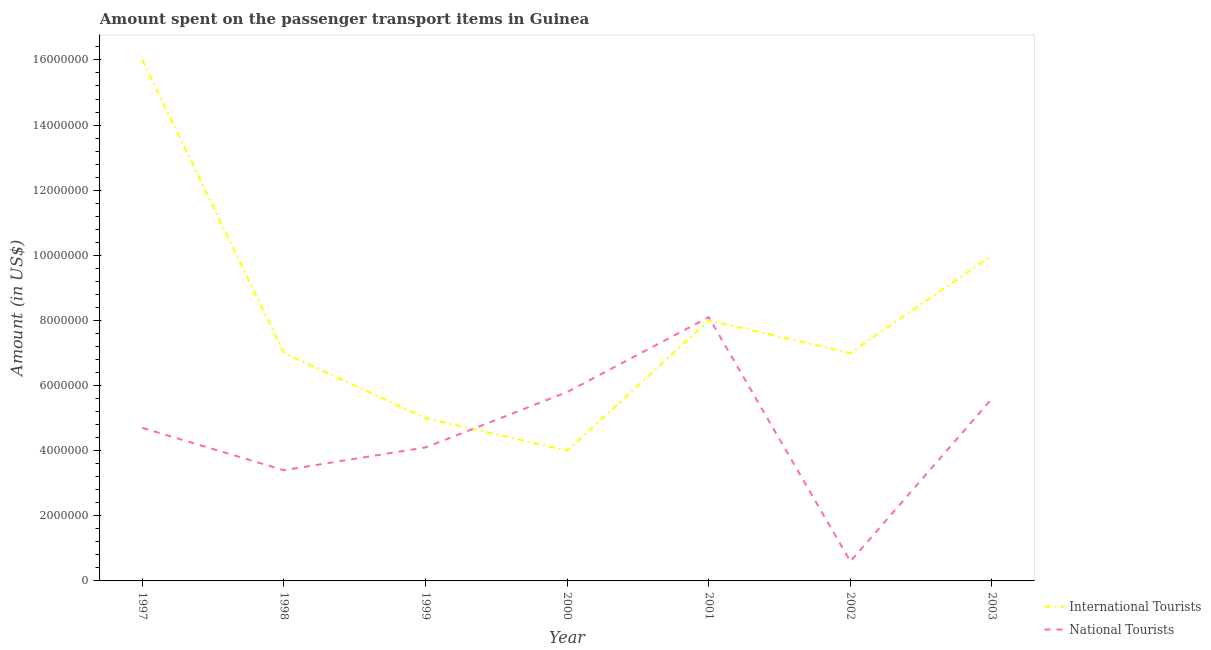Does the line corresponding to amount spent on transport items of international tourists intersect with the line corresponding to amount spent on transport items of national tourists?
Provide a succinct answer. Yes. Is the number of lines equal to the number of legend labels?
Your answer should be compact. Yes. What is the amount spent on transport items of international tourists in 1998?
Offer a very short reply. 7.00e+06. Across all years, what is the maximum amount spent on transport items of national tourists?
Provide a short and direct response. 8.10e+06. Across all years, what is the minimum amount spent on transport items of national tourists?
Offer a terse response. 6.00e+05. In which year was the amount spent on transport items of international tourists maximum?
Your answer should be compact. 1997. In which year was the amount spent on transport items of national tourists minimum?
Your answer should be very brief. 2002. What is the total amount spent on transport items of national tourists in the graph?
Provide a short and direct response. 3.23e+07. What is the difference between the amount spent on transport items of international tourists in 2002 and that in 2003?
Provide a succinct answer. -3.00e+06. What is the difference between the amount spent on transport items of national tourists in 1999 and the amount spent on transport items of international tourists in 1997?
Provide a short and direct response. -1.19e+07. What is the average amount spent on transport items of national tourists per year?
Ensure brevity in your answer.  4.61e+06. In the year 2003, what is the difference between the amount spent on transport items of international tourists and amount spent on transport items of national tourists?
Give a very brief answer. 4.40e+06. In how many years, is the amount spent on transport items of international tourists greater than 1600000 US$?
Your answer should be compact. 7. What is the ratio of the amount spent on transport items of national tourists in 1998 to that in 2001?
Provide a succinct answer. 0.42. Is the difference between the amount spent on transport items of national tourists in 1998 and 2002 greater than the difference between the amount spent on transport items of international tourists in 1998 and 2002?
Give a very brief answer. Yes. What is the difference between the highest and the lowest amount spent on transport items of national tourists?
Make the answer very short. 7.50e+06. Does the amount spent on transport items of international tourists monotonically increase over the years?
Make the answer very short. No. Is the amount spent on transport items of national tourists strictly greater than the amount spent on transport items of international tourists over the years?
Your response must be concise. No. How many lines are there?
Keep it short and to the point. 2. How many years are there in the graph?
Your response must be concise. 7. Are the values on the major ticks of Y-axis written in scientific E-notation?
Offer a very short reply. No. Does the graph contain grids?
Make the answer very short. No. Where does the legend appear in the graph?
Make the answer very short. Bottom right. How are the legend labels stacked?
Ensure brevity in your answer.  Vertical. What is the title of the graph?
Offer a terse response. Amount spent on the passenger transport items in Guinea. What is the Amount (in US$) in International Tourists in 1997?
Make the answer very short. 1.60e+07. What is the Amount (in US$) in National Tourists in 1997?
Offer a very short reply. 4.70e+06. What is the Amount (in US$) in National Tourists in 1998?
Keep it short and to the point. 3.40e+06. What is the Amount (in US$) of National Tourists in 1999?
Ensure brevity in your answer.  4.10e+06. What is the Amount (in US$) in International Tourists in 2000?
Provide a short and direct response. 4.00e+06. What is the Amount (in US$) of National Tourists in 2000?
Your answer should be compact. 5.80e+06. What is the Amount (in US$) in International Tourists in 2001?
Your response must be concise. 8.00e+06. What is the Amount (in US$) of National Tourists in 2001?
Your answer should be compact. 8.10e+06. What is the Amount (in US$) in International Tourists in 2002?
Ensure brevity in your answer.  7.00e+06. What is the Amount (in US$) of International Tourists in 2003?
Give a very brief answer. 1.00e+07. What is the Amount (in US$) in National Tourists in 2003?
Ensure brevity in your answer.  5.60e+06. Across all years, what is the maximum Amount (in US$) of International Tourists?
Make the answer very short. 1.60e+07. Across all years, what is the maximum Amount (in US$) in National Tourists?
Make the answer very short. 8.10e+06. Across all years, what is the minimum Amount (in US$) of National Tourists?
Make the answer very short. 6.00e+05. What is the total Amount (in US$) of International Tourists in the graph?
Provide a succinct answer. 5.70e+07. What is the total Amount (in US$) in National Tourists in the graph?
Offer a very short reply. 3.23e+07. What is the difference between the Amount (in US$) in International Tourists in 1997 and that in 1998?
Your answer should be compact. 9.00e+06. What is the difference between the Amount (in US$) of National Tourists in 1997 and that in 1998?
Provide a succinct answer. 1.30e+06. What is the difference between the Amount (in US$) in International Tourists in 1997 and that in 1999?
Make the answer very short. 1.10e+07. What is the difference between the Amount (in US$) in National Tourists in 1997 and that in 1999?
Ensure brevity in your answer.  6.00e+05. What is the difference between the Amount (in US$) in National Tourists in 1997 and that in 2000?
Offer a very short reply. -1.10e+06. What is the difference between the Amount (in US$) in National Tourists in 1997 and that in 2001?
Provide a short and direct response. -3.40e+06. What is the difference between the Amount (in US$) of International Tourists in 1997 and that in 2002?
Your answer should be compact. 9.00e+06. What is the difference between the Amount (in US$) of National Tourists in 1997 and that in 2002?
Provide a short and direct response. 4.10e+06. What is the difference between the Amount (in US$) in International Tourists in 1997 and that in 2003?
Provide a succinct answer. 6.00e+06. What is the difference between the Amount (in US$) in National Tourists in 1997 and that in 2003?
Offer a very short reply. -9.00e+05. What is the difference between the Amount (in US$) in International Tourists in 1998 and that in 1999?
Ensure brevity in your answer.  2.00e+06. What is the difference between the Amount (in US$) in National Tourists in 1998 and that in 1999?
Your response must be concise. -7.00e+05. What is the difference between the Amount (in US$) of National Tourists in 1998 and that in 2000?
Provide a succinct answer. -2.40e+06. What is the difference between the Amount (in US$) in International Tourists in 1998 and that in 2001?
Keep it short and to the point. -1.00e+06. What is the difference between the Amount (in US$) in National Tourists in 1998 and that in 2001?
Your answer should be compact. -4.70e+06. What is the difference between the Amount (in US$) in National Tourists in 1998 and that in 2002?
Offer a very short reply. 2.80e+06. What is the difference between the Amount (in US$) in National Tourists in 1998 and that in 2003?
Provide a succinct answer. -2.20e+06. What is the difference between the Amount (in US$) in National Tourists in 1999 and that in 2000?
Offer a very short reply. -1.70e+06. What is the difference between the Amount (in US$) in National Tourists in 1999 and that in 2001?
Ensure brevity in your answer.  -4.00e+06. What is the difference between the Amount (in US$) of National Tourists in 1999 and that in 2002?
Offer a very short reply. 3.50e+06. What is the difference between the Amount (in US$) in International Tourists in 1999 and that in 2003?
Your response must be concise. -5.00e+06. What is the difference between the Amount (in US$) of National Tourists in 1999 and that in 2003?
Your answer should be very brief. -1.50e+06. What is the difference between the Amount (in US$) in International Tourists in 2000 and that in 2001?
Provide a succinct answer. -4.00e+06. What is the difference between the Amount (in US$) of National Tourists in 2000 and that in 2001?
Give a very brief answer. -2.30e+06. What is the difference between the Amount (in US$) in International Tourists in 2000 and that in 2002?
Your answer should be compact. -3.00e+06. What is the difference between the Amount (in US$) in National Tourists in 2000 and that in 2002?
Your answer should be compact. 5.20e+06. What is the difference between the Amount (in US$) of International Tourists in 2000 and that in 2003?
Offer a very short reply. -6.00e+06. What is the difference between the Amount (in US$) of National Tourists in 2001 and that in 2002?
Your answer should be very brief. 7.50e+06. What is the difference between the Amount (in US$) of International Tourists in 2001 and that in 2003?
Make the answer very short. -2.00e+06. What is the difference between the Amount (in US$) in National Tourists in 2001 and that in 2003?
Offer a terse response. 2.50e+06. What is the difference between the Amount (in US$) in International Tourists in 2002 and that in 2003?
Ensure brevity in your answer.  -3.00e+06. What is the difference between the Amount (in US$) in National Tourists in 2002 and that in 2003?
Your answer should be compact. -5.00e+06. What is the difference between the Amount (in US$) in International Tourists in 1997 and the Amount (in US$) in National Tourists in 1998?
Your response must be concise. 1.26e+07. What is the difference between the Amount (in US$) in International Tourists in 1997 and the Amount (in US$) in National Tourists in 1999?
Your response must be concise. 1.19e+07. What is the difference between the Amount (in US$) of International Tourists in 1997 and the Amount (in US$) of National Tourists in 2000?
Your answer should be very brief. 1.02e+07. What is the difference between the Amount (in US$) of International Tourists in 1997 and the Amount (in US$) of National Tourists in 2001?
Make the answer very short. 7.90e+06. What is the difference between the Amount (in US$) in International Tourists in 1997 and the Amount (in US$) in National Tourists in 2002?
Provide a succinct answer. 1.54e+07. What is the difference between the Amount (in US$) in International Tourists in 1997 and the Amount (in US$) in National Tourists in 2003?
Your answer should be very brief. 1.04e+07. What is the difference between the Amount (in US$) in International Tourists in 1998 and the Amount (in US$) in National Tourists in 1999?
Keep it short and to the point. 2.90e+06. What is the difference between the Amount (in US$) of International Tourists in 1998 and the Amount (in US$) of National Tourists in 2000?
Your answer should be very brief. 1.20e+06. What is the difference between the Amount (in US$) of International Tourists in 1998 and the Amount (in US$) of National Tourists in 2001?
Your answer should be very brief. -1.10e+06. What is the difference between the Amount (in US$) in International Tourists in 1998 and the Amount (in US$) in National Tourists in 2002?
Offer a very short reply. 6.40e+06. What is the difference between the Amount (in US$) of International Tourists in 1998 and the Amount (in US$) of National Tourists in 2003?
Ensure brevity in your answer.  1.40e+06. What is the difference between the Amount (in US$) of International Tourists in 1999 and the Amount (in US$) of National Tourists in 2000?
Provide a short and direct response. -8.00e+05. What is the difference between the Amount (in US$) in International Tourists in 1999 and the Amount (in US$) in National Tourists in 2001?
Provide a succinct answer. -3.10e+06. What is the difference between the Amount (in US$) in International Tourists in 1999 and the Amount (in US$) in National Tourists in 2002?
Your response must be concise. 4.40e+06. What is the difference between the Amount (in US$) of International Tourists in 1999 and the Amount (in US$) of National Tourists in 2003?
Your answer should be compact. -6.00e+05. What is the difference between the Amount (in US$) in International Tourists in 2000 and the Amount (in US$) in National Tourists in 2001?
Give a very brief answer. -4.10e+06. What is the difference between the Amount (in US$) in International Tourists in 2000 and the Amount (in US$) in National Tourists in 2002?
Offer a very short reply. 3.40e+06. What is the difference between the Amount (in US$) in International Tourists in 2000 and the Amount (in US$) in National Tourists in 2003?
Keep it short and to the point. -1.60e+06. What is the difference between the Amount (in US$) in International Tourists in 2001 and the Amount (in US$) in National Tourists in 2002?
Make the answer very short. 7.40e+06. What is the difference between the Amount (in US$) in International Tourists in 2001 and the Amount (in US$) in National Tourists in 2003?
Keep it short and to the point. 2.40e+06. What is the difference between the Amount (in US$) in International Tourists in 2002 and the Amount (in US$) in National Tourists in 2003?
Give a very brief answer. 1.40e+06. What is the average Amount (in US$) of International Tourists per year?
Provide a short and direct response. 8.14e+06. What is the average Amount (in US$) of National Tourists per year?
Your answer should be very brief. 4.61e+06. In the year 1997, what is the difference between the Amount (in US$) of International Tourists and Amount (in US$) of National Tourists?
Make the answer very short. 1.13e+07. In the year 1998, what is the difference between the Amount (in US$) in International Tourists and Amount (in US$) in National Tourists?
Your answer should be compact. 3.60e+06. In the year 1999, what is the difference between the Amount (in US$) in International Tourists and Amount (in US$) in National Tourists?
Make the answer very short. 9.00e+05. In the year 2000, what is the difference between the Amount (in US$) in International Tourists and Amount (in US$) in National Tourists?
Provide a succinct answer. -1.80e+06. In the year 2001, what is the difference between the Amount (in US$) in International Tourists and Amount (in US$) in National Tourists?
Offer a terse response. -1.00e+05. In the year 2002, what is the difference between the Amount (in US$) in International Tourists and Amount (in US$) in National Tourists?
Keep it short and to the point. 6.40e+06. In the year 2003, what is the difference between the Amount (in US$) of International Tourists and Amount (in US$) of National Tourists?
Your answer should be very brief. 4.40e+06. What is the ratio of the Amount (in US$) in International Tourists in 1997 to that in 1998?
Your answer should be very brief. 2.29. What is the ratio of the Amount (in US$) of National Tourists in 1997 to that in 1998?
Keep it short and to the point. 1.38. What is the ratio of the Amount (in US$) in National Tourists in 1997 to that in 1999?
Give a very brief answer. 1.15. What is the ratio of the Amount (in US$) of National Tourists in 1997 to that in 2000?
Offer a terse response. 0.81. What is the ratio of the Amount (in US$) of International Tourists in 1997 to that in 2001?
Your answer should be very brief. 2. What is the ratio of the Amount (in US$) in National Tourists in 1997 to that in 2001?
Offer a terse response. 0.58. What is the ratio of the Amount (in US$) in International Tourists in 1997 to that in 2002?
Ensure brevity in your answer.  2.29. What is the ratio of the Amount (in US$) in National Tourists in 1997 to that in 2002?
Ensure brevity in your answer.  7.83. What is the ratio of the Amount (in US$) of International Tourists in 1997 to that in 2003?
Offer a very short reply. 1.6. What is the ratio of the Amount (in US$) in National Tourists in 1997 to that in 2003?
Keep it short and to the point. 0.84. What is the ratio of the Amount (in US$) in National Tourists in 1998 to that in 1999?
Offer a very short reply. 0.83. What is the ratio of the Amount (in US$) of International Tourists in 1998 to that in 2000?
Give a very brief answer. 1.75. What is the ratio of the Amount (in US$) in National Tourists in 1998 to that in 2000?
Your answer should be compact. 0.59. What is the ratio of the Amount (in US$) of International Tourists in 1998 to that in 2001?
Ensure brevity in your answer.  0.88. What is the ratio of the Amount (in US$) of National Tourists in 1998 to that in 2001?
Offer a terse response. 0.42. What is the ratio of the Amount (in US$) in National Tourists in 1998 to that in 2002?
Offer a terse response. 5.67. What is the ratio of the Amount (in US$) of National Tourists in 1998 to that in 2003?
Ensure brevity in your answer.  0.61. What is the ratio of the Amount (in US$) in National Tourists in 1999 to that in 2000?
Your answer should be very brief. 0.71. What is the ratio of the Amount (in US$) in National Tourists in 1999 to that in 2001?
Your answer should be very brief. 0.51. What is the ratio of the Amount (in US$) of International Tourists in 1999 to that in 2002?
Ensure brevity in your answer.  0.71. What is the ratio of the Amount (in US$) in National Tourists in 1999 to that in 2002?
Provide a succinct answer. 6.83. What is the ratio of the Amount (in US$) in National Tourists in 1999 to that in 2003?
Ensure brevity in your answer.  0.73. What is the ratio of the Amount (in US$) of International Tourists in 2000 to that in 2001?
Your answer should be compact. 0.5. What is the ratio of the Amount (in US$) in National Tourists in 2000 to that in 2001?
Ensure brevity in your answer.  0.72. What is the ratio of the Amount (in US$) of National Tourists in 2000 to that in 2002?
Offer a terse response. 9.67. What is the ratio of the Amount (in US$) in National Tourists in 2000 to that in 2003?
Give a very brief answer. 1.04. What is the ratio of the Amount (in US$) of International Tourists in 2001 to that in 2002?
Offer a very short reply. 1.14. What is the ratio of the Amount (in US$) in International Tourists in 2001 to that in 2003?
Make the answer very short. 0.8. What is the ratio of the Amount (in US$) in National Tourists in 2001 to that in 2003?
Your answer should be very brief. 1.45. What is the ratio of the Amount (in US$) in International Tourists in 2002 to that in 2003?
Offer a terse response. 0.7. What is the ratio of the Amount (in US$) in National Tourists in 2002 to that in 2003?
Provide a short and direct response. 0.11. What is the difference between the highest and the second highest Amount (in US$) of International Tourists?
Offer a terse response. 6.00e+06. What is the difference between the highest and the second highest Amount (in US$) of National Tourists?
Give a very brief answer. 2.30e+06. What is the difference between the highest and the lowest Amount (in US$) of International Tourists?
Keep it short and to the point. 1.20e+07. What is the difference between the highest and the lowest Amount (in US$) in National Tourists?
Ensure brevity in your answer.  7.50e+06. 